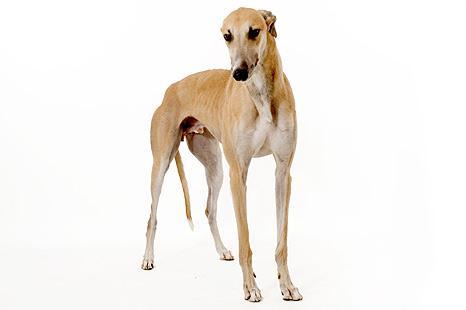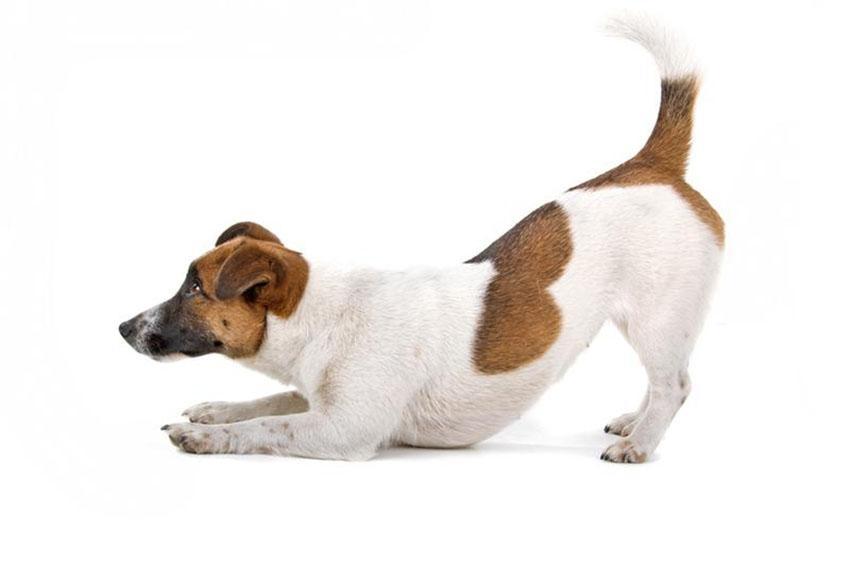The first image is the image on the left, the second image is the image on the right. For the images shown, is this caption "Each image features a hound dog posed with its front half lowered and its hind haunches raised." true? Answer yes or no. No. The first image is the image on the left, the second image is the image on the right. Considering the images on both sides, is "Both dogs are leaning on their front legs." valid? Answer yes or no. No. 